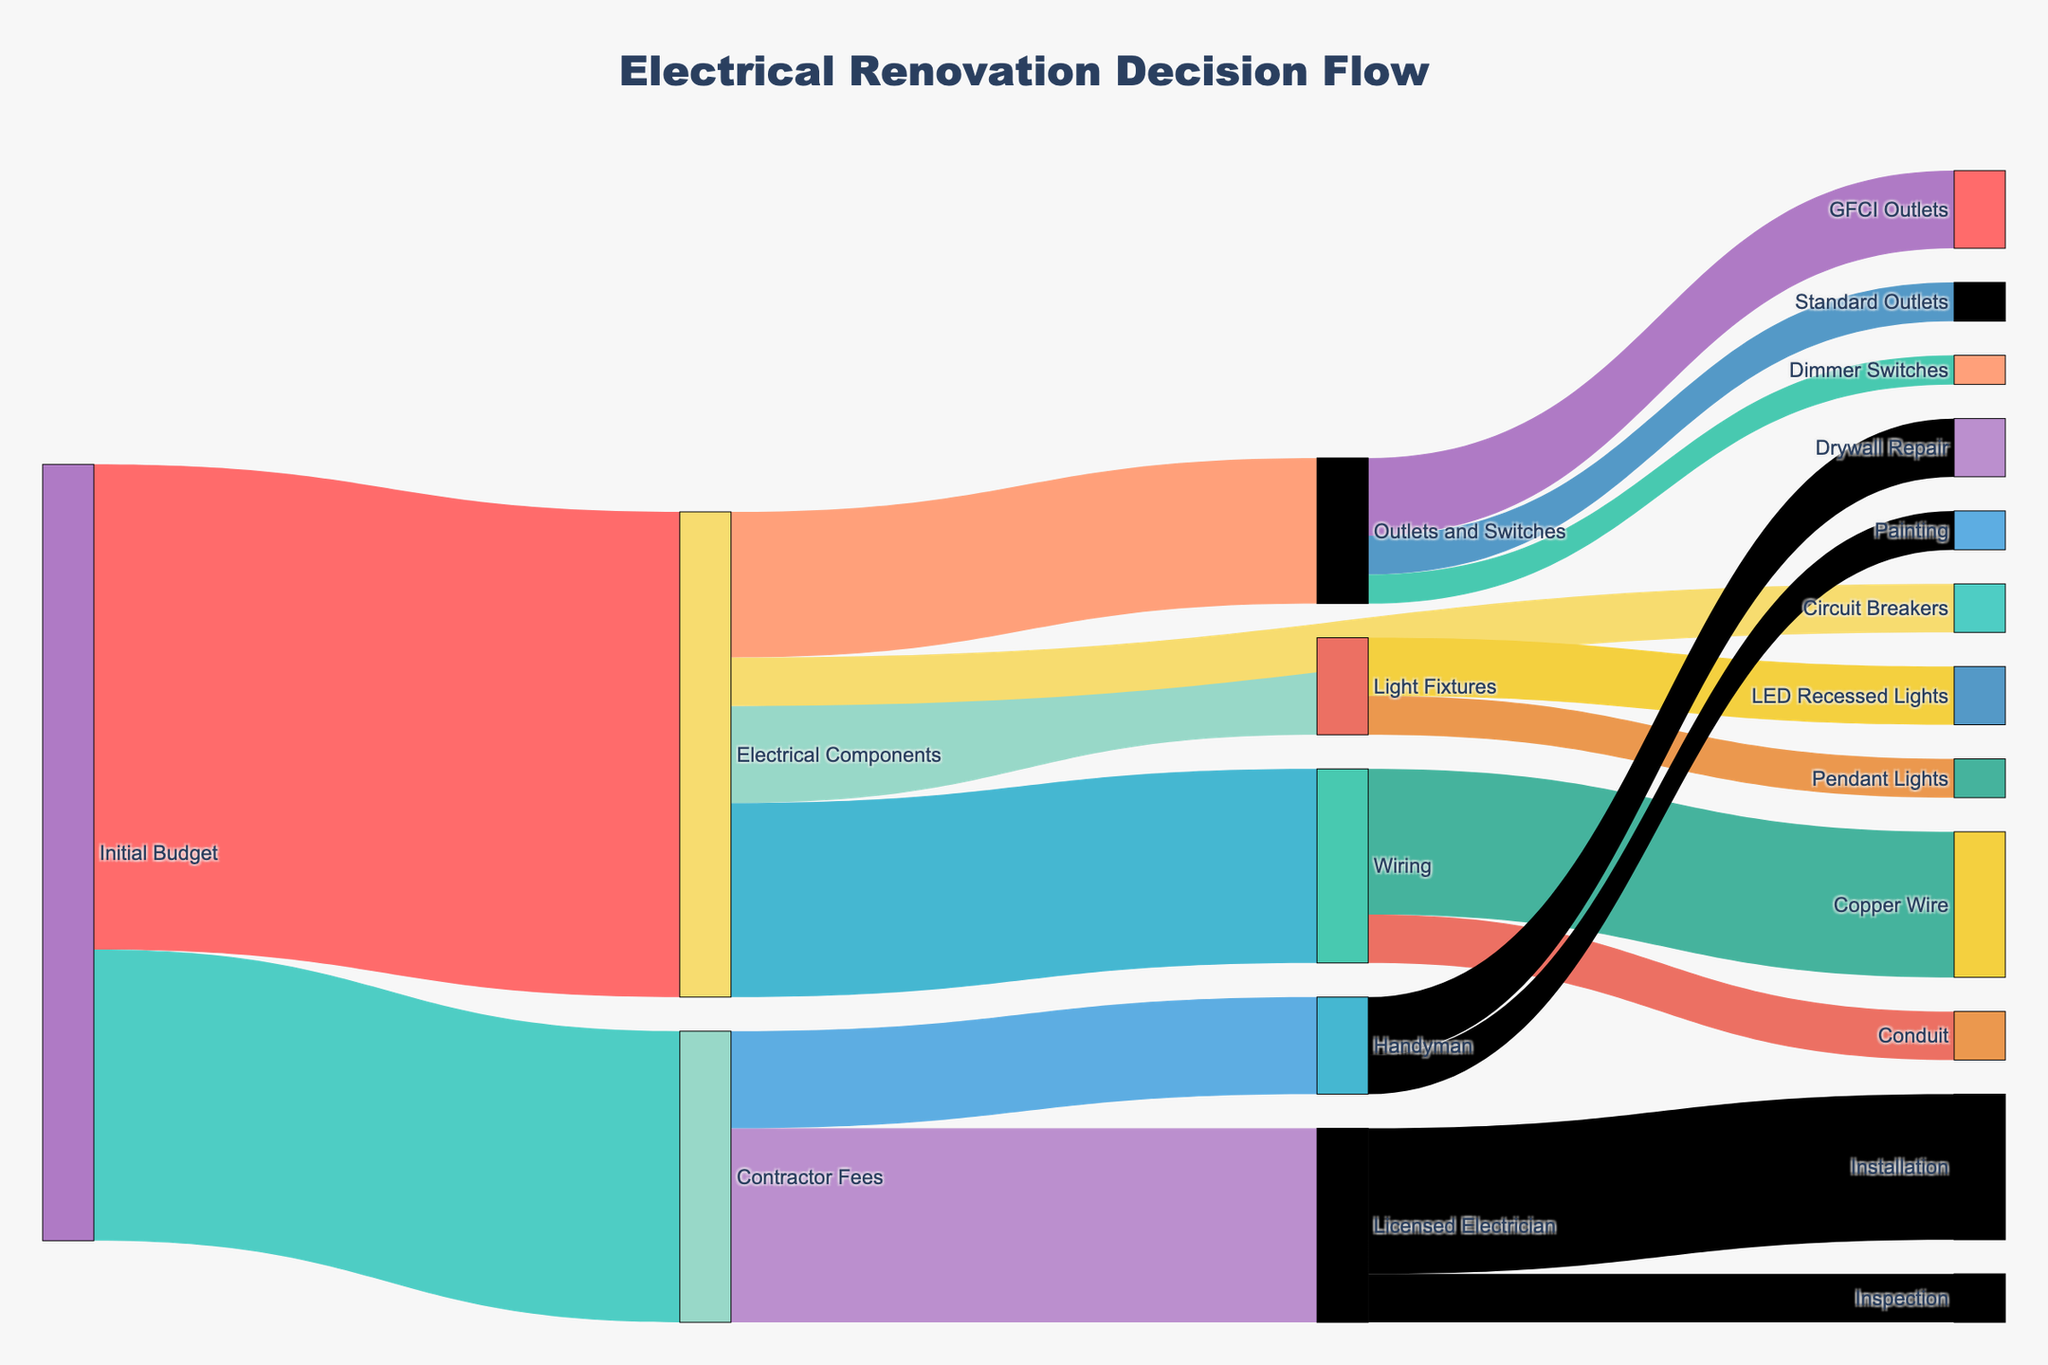How many node categories are there overall? To determine the number of categories, count each unique label listed under nodes. The categories are Initial Budget, Electrical Components, Contractor Fees, Wiring, Outlets and Switches, Light Fixtures, Circuit Breakers, Licensed Electrician, Handyman, Copper Wire, Conduit, GFCI Outlets, Standard Outlets, Dimmer Switches, LED Recessed Lights, Pendant Lights, Inspection, Installation, Drywall Repair, and Painting.
Answer: 19 What is the value assigned to Light Fixtures from Electrical Components? By tracing the path from Electrical Components to Light Fixtures in the diagram, you see the value assigned is 1000.
Answer: 1000 What is the value assigned to Copper Wire from Wiring? By following the link from Wiring to Copper Wire, you observe the value assigned is 1500.
Answer: 1500 What is the combined value spent on Licensed Electrician and Handyman? Add the individual values directed to Licensed Electrician and Handyman. The values are 2000 and 1000, respectively. So, 2000 + 1000 = 3000.
Answer: 3000 Between LED Recessed Lights and Pendant Lights, which receives more value, and by how much? Compare the values directed toward LED Recessed Lights (600) and Pendant Lights (400). The difference is 600 - 400 = 200. LED Recessed Lights receive more by 200.
Answer: LED Recessed Lights by 200 How much more is spent on Wiring compared to Outlets and Switches? Compare the values directed toward Wiring (2000) and Outlets and Switches (1500). The difference is 2000 - 1500 = 500. Wiring receives 500 more.
Answer: 500 What is the total amount allocated to Electrical Components? Sum the values entering Electrical Components. They are Wiring (2000), Outlets and Switches (1500), Light Fixtures (1000), and Circuit Breakers (500). So, 2000 + 1500 + 1000 + 500 = 5000.
Answer: 5000 What portion of the Contractor Fees is allocated to the Licensed Electrician for Installation? First, find the portion allocated to Installation by Licensed Electrician (1500). Then, calculate the portion relative to Contractor Fees (3000). The ratio is 1500/3000 = 0.5, so 50%.
Answer: 50% Which sub-category under Contractor Fees has the least value, and what is it? Compare all the values under Contractor Fees: Inspection (500), Installation (1500), Drywall Repair (600), and Painting (400). The least value is Painting, with 400.
Answer: Painting, 400 